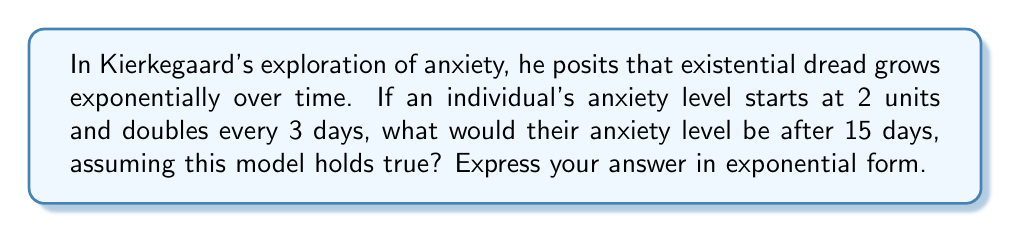Can you answer this question? Let's approach this step-by-step:

1) We start with an initial anxiety level of 2 units.

2) The anxiety doubles every 3 days. This means we can express this as an exponential function:

   $A(t) = 2 \cdot 2^{\frac{t}{3}}$

   Where $A(t)$ is the anxiety level after $t$ days, and 2 is our initial value.

3) We want to know the anxiety level after 15 days, so we plug in $t = 15$:

   $A(15) = 2 \cdot 2^{\frac{15}{3}}$

4) Simplify the exponent:

   $A(15) = 2 \cdot 2^5$

5) We could calculate this further, but the question asks for the answer in exponential form, so we'll leave it as is.
Answer: $2 \cdot 2^5$ 